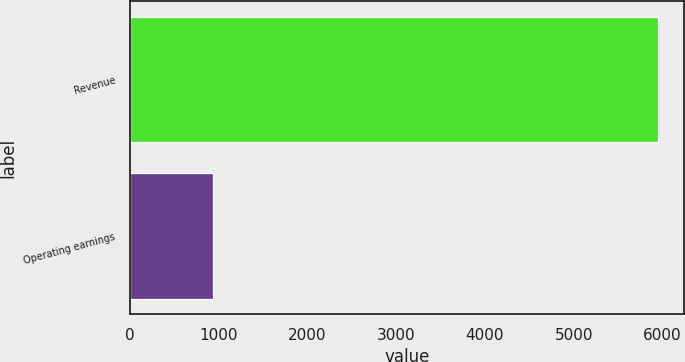Convert chart to OTSL. <chart><loc_0><loc_0><loc_500><loc_500><bar_chart><fcel>Revenue<fcel>Operating earnings<nl><fcel>5949<fcel>937<nl></chart> 